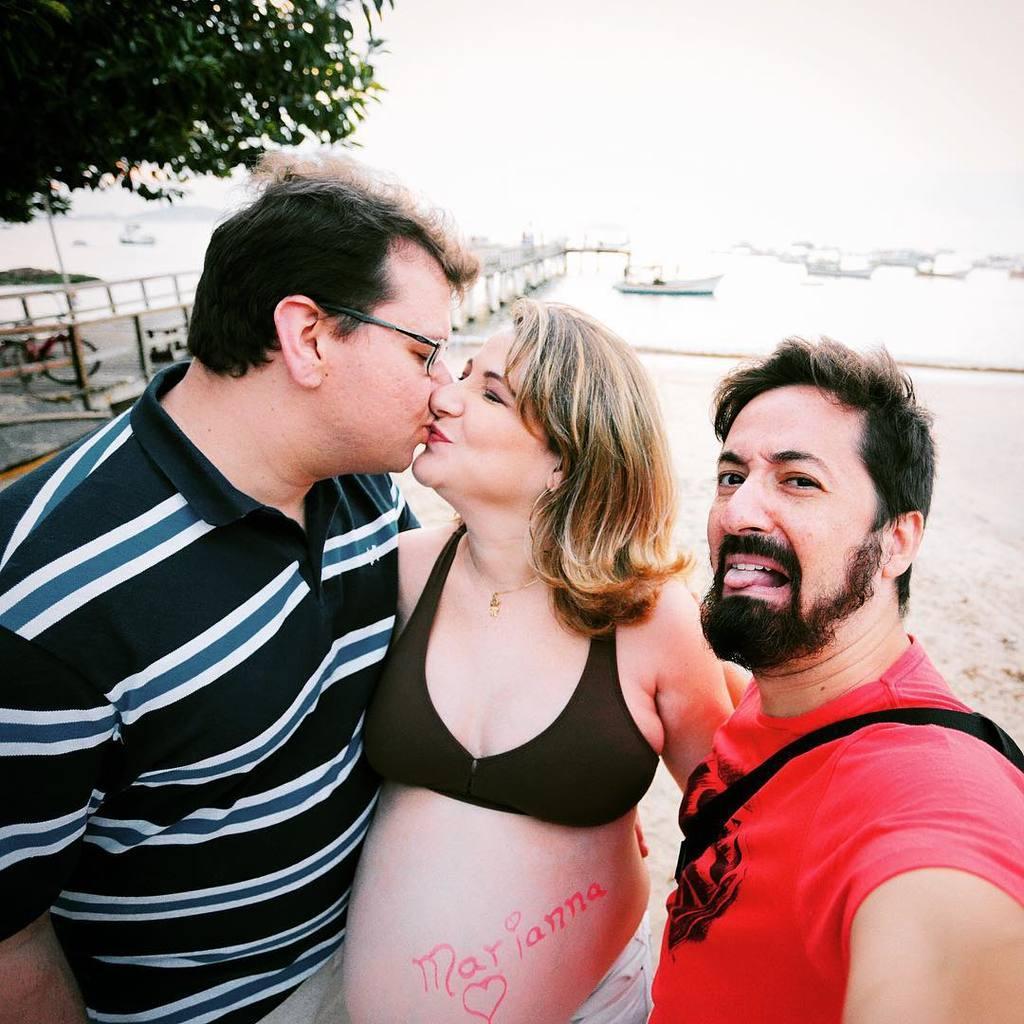How would you summarize this image in a sentence or two? In this image we can see two men and women standing on the sand. In the background we can see boats, sea, tree, bridge and cycle. 